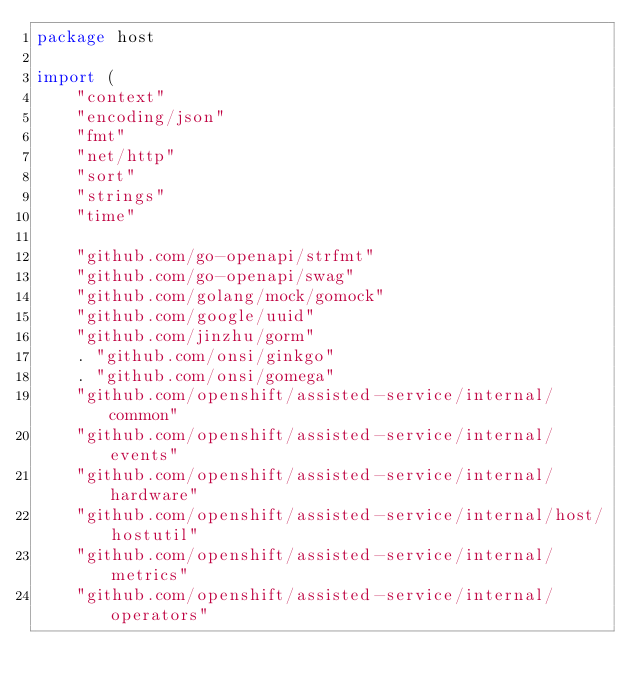Convert code to text. <code><loc_0><loc_0><loc_500><loc_500><_Go_>package host

import (
	"context"
	"encoding/json"
	"fmt"
	"net/http"
	"sort"
	"strings"
	"time"

	"github.com/go-openapi/strfmt"
	"github.com/go-openapi/swag"
	"github.com/golang/mock/gomock"
	"github.com/google/uuid"
	"github.com/jinzhu/gorm"
	. "github.com/onsi/ginkgo"
	. "github.com/onsi/gomega"
	"github.com/openshift/assisted-service/internal/common"
	"github.com/openshift/assisted-service/internal/events"
	"github.com/openshift/assisted-service/internal/hardware"
	"github.com/openshift/assisted-service/internal/host/hostutil"
	"github.com/openshift/assisted-service/internal/metrics"
	"github.com/openshift/assisted-service/internal/operators"</code> 